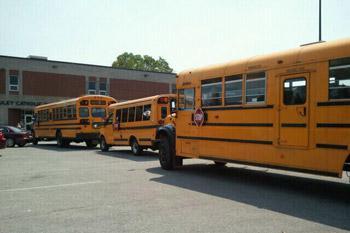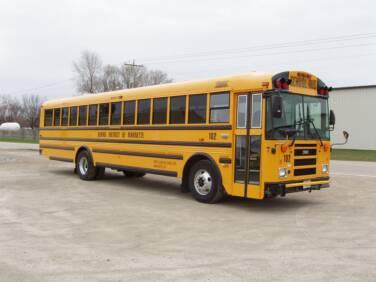The first image is the image on the left, the second image is the image on the right. Considering the images on both sides, is "There are more buses in the image on the left." valid? Answer yes or no. Yes. The first image is the image on the left, the second image is the image on the right. For the images shown, is this caption "The right image shows one flat-fronted bus displayed diagonally and forward-facing, and the left image includes at least one bus that has a non-flat front." true? Answer yes or no. Yes. 